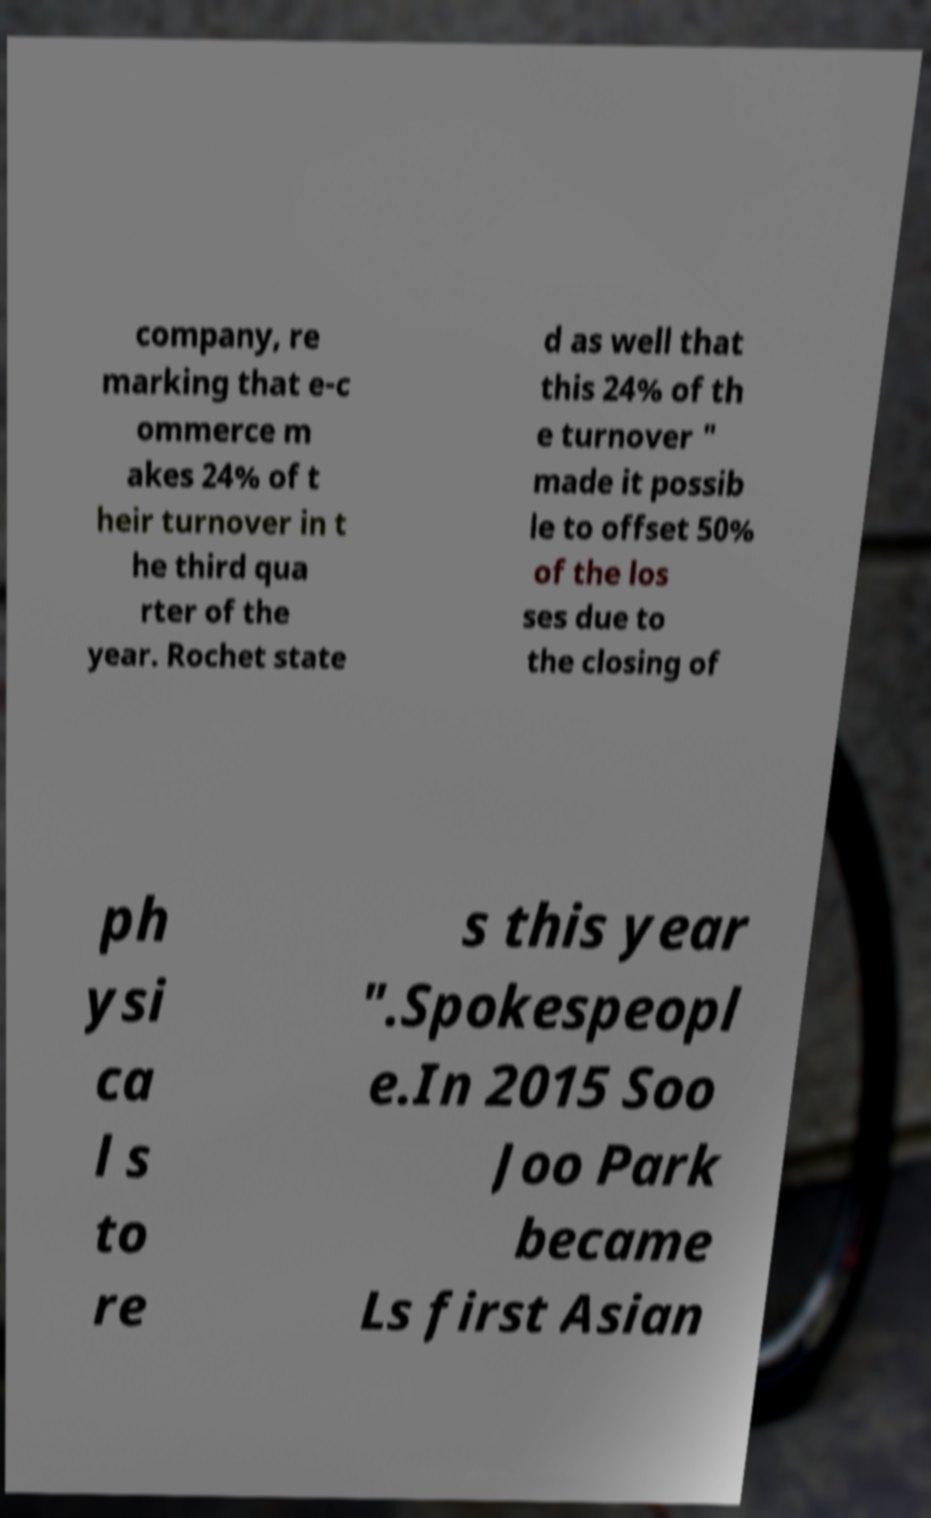Can you read and provide the text displayed in the image?This photo seems to have some interesting text. Can you extract and type it out for me? company, re marking that e-c ommerce m akes 24% of t heir turnover in t he third qua rter of the year. Rochet state d as well that this 24% of th e turnover " made it possib le to offset 50% of the los ses due to the closing of ph ysi ca l s to re s this year ".Spokespeopl e.In 2015 Soo Joo Park became Ls first Asian 